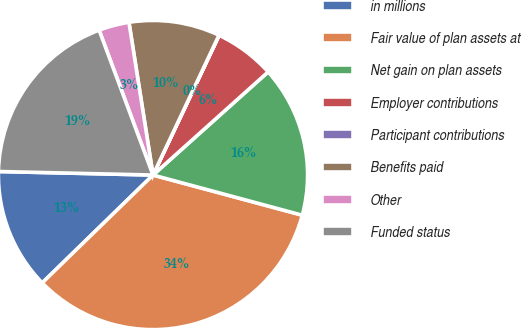<chart> <loc_0><loc_0><loc_500><loc_500><pie_chart><fcel>in millions<fcel>Fair value of plan assets at<fcel>Net gain on plan assets<fcel>Employer contributions<fcel>Participant contributions<fcel>Benefits paid<fcel>Other<fcel>Funded status<nl><fcel>12.65%<fcel>33.53%<fcel>15.81%<fcel>6.34%<fcel>0.02%<fcel>9.5%<fcel>3.18%<fcel>18.97%<nl></chart> 